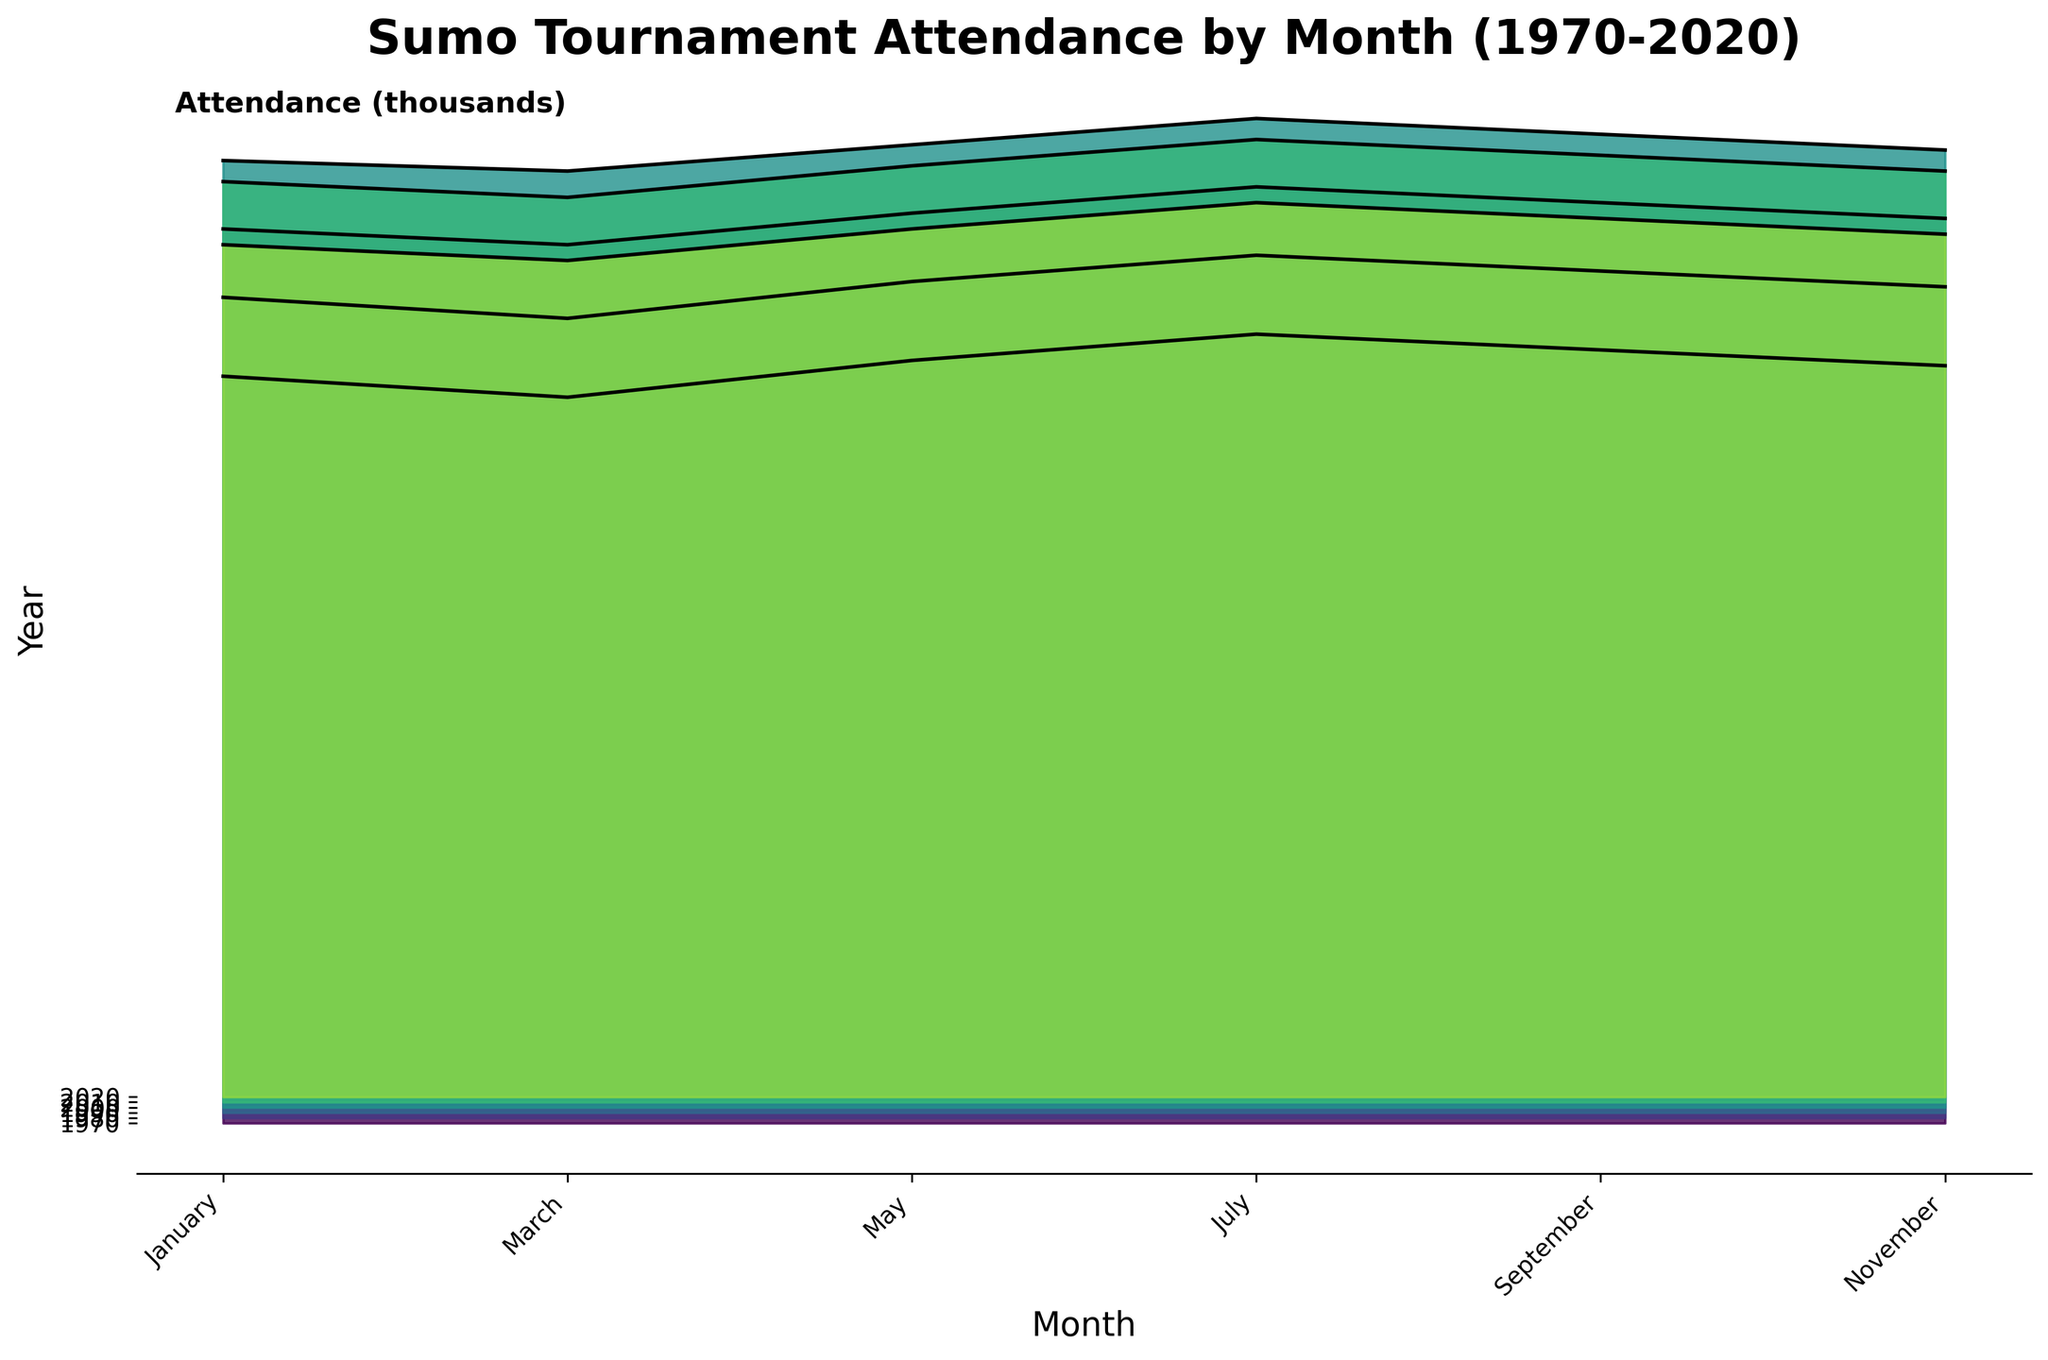What is the title of the plot? The title is usually placed at the top of the plot and is meant to describe the main topic of the visualization
Answer: Sumo Tournament Attendance by Month (1970-2020) Which month had the highest attendance in the year 2000? Locate the line corresponding to the year 2000, and identify which month has the peak value
Answer: July By how much did attendance in May increase from 1970 to 2020? Find the attendance for May in both 1970 and 2020 from the plot, then subtract the 1970 value from the 2020 value
Answer: 20,000 Did any years have a decline in attendance from one decade to the next? Compare the attendance values for each month between successive decades to identify any decreasing trends
Answer: Yes What is the average attendance for the month of September over the years? Sum the attendance values for September in each year and divide by the number of years considered
Answer: 168,833.33 Which month generally maintains the highest attendance across all years? Visually assess each month's position in the plot to determine which maintains the highest values over the entire period
Answer: July Was there a constant increase in attendance every decade? Examine the attendance values at each decade mark for each month to see if they increased consistently or if there were fluctuations
Answer: No How does the attendance in November 1990 compare to November 2010? Locate the values for November in the years 1990 and 2010 and compare them
Answer: Attendance in 2010 is higher than in 1990 What trend is observed in spectator attendance from 2010 to 2020? Observe the lines or fillings for each month between the years 2010 and 2020 to determine if there is an increasing, decreasing, or stable trend
Answer: Decreasing trend Which decade saw the most significant rise in attendance for the month of March? Compare the increase in attendance from one decade to the next for March and identify the most substantial increase
Answer: From 1970 to 1980 